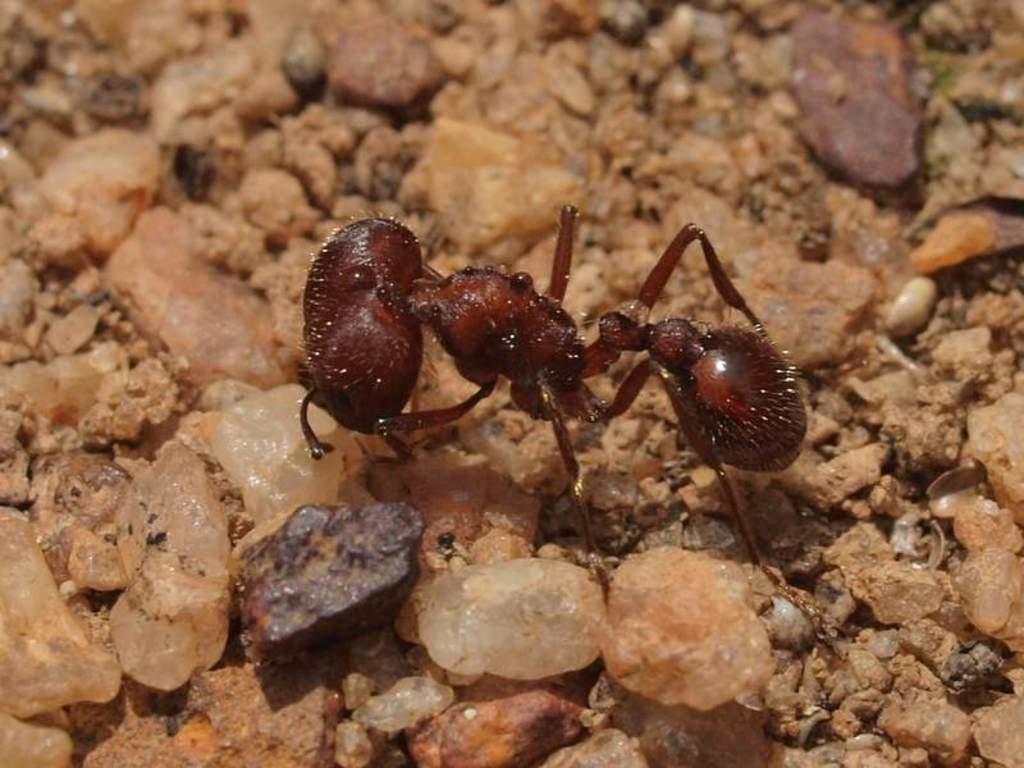What is the main subject of the image? There is an ant in the image. Where is the ant located? The ant is on the ground. What else can be seen on the ground in the image? There are stones on the ground in the image. Which direction is the mitten facing in the image? There is no mitten present in the image. 